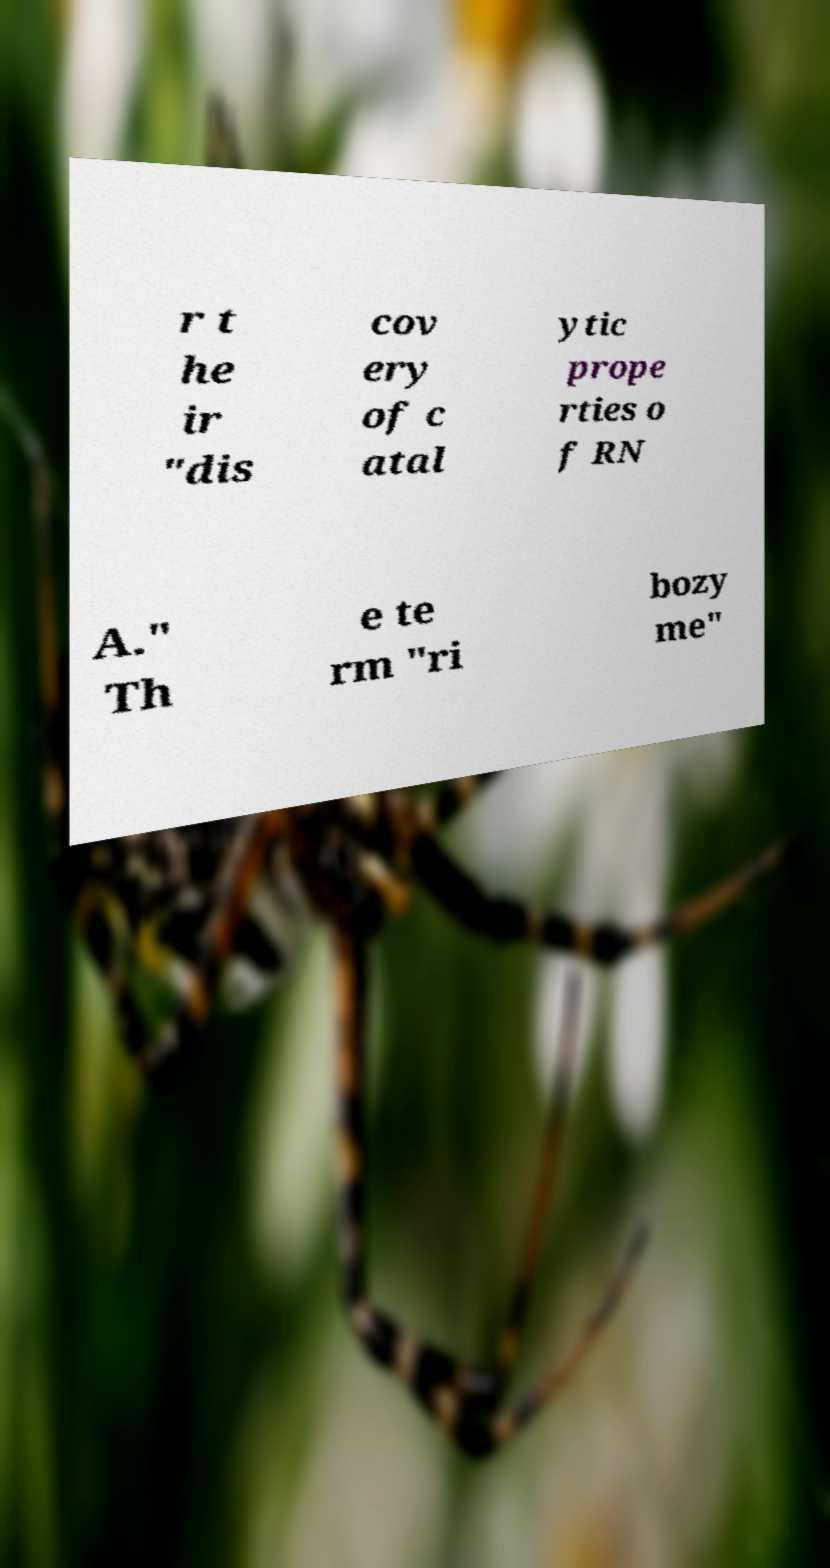What messages or text are displayed in this image? I need them in a readable, typed format. r t he ir "dis cov ery of c atal ytic prope rties o f RN A." Th e te rm "ri bozy me" 